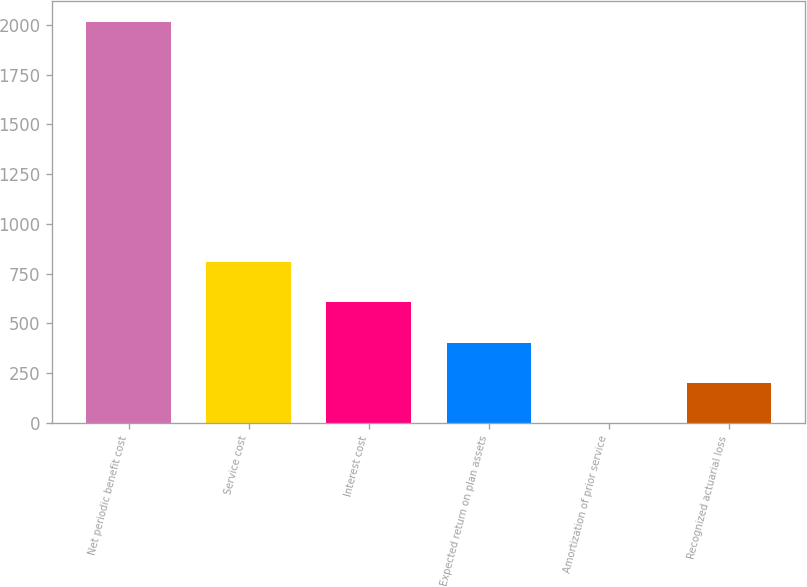<chart> <loc_0><loc_0><loc_500><loc_500><bar_chart><fcel>Net periodic benefit cost<fcel>Service cost<fcel>Interest cost<fcel>Expected return on plan assets<fcel>Amortization of prior service<fcel>Recognized actuarial loss<nl><fcel>2016<fcel>807<fcel>605.5<fcel>404<fcel>1<fcel>202.5<nl></chart> 